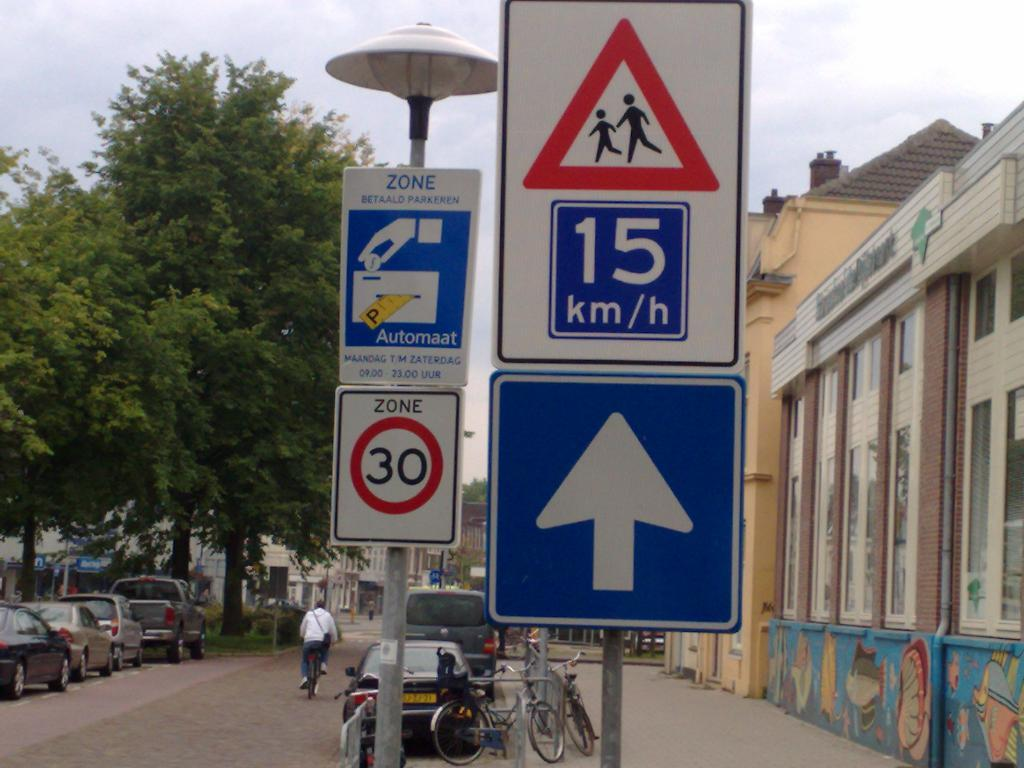<image>
Describe the image concisely. A blue sign says 15 km/h and a bike rack is behind it. 